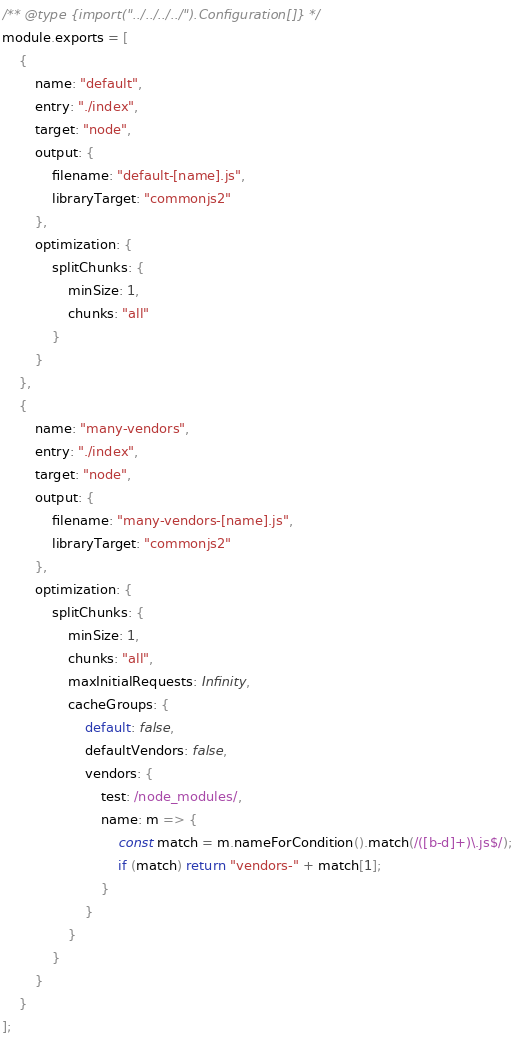<code> <loc_0><loc_0><loc_500><loc_500><_JavaScript_>/** @type {import("../../../../").Configuration[]} */
module.exports = [
	{
		name: "default",
		entry: "./index",
		target: "node",
		output: {
			filename: "default-[name].js",
			libraryTarget: "commonjs2"
		},
		optimization: {
			splitChunks: {
				minSize: 1,
				chunks: "all"
			}
		}
	},
	{
		name: "many-vendors",
		entry: "./index",
		target: "node",
		output: {
			filename: "many-vendors-[name].js",
			libraryTarget: "commonjs2"
		},
		optimization: {
			splitChunks: {
				minSize: 1,
				chunks: "all",
				maxInitialRequests: Infinity,
				cacheGroups: {
					default: false,
					defaultVendors: false,
					vendors: {
						test: /node_modules/,
						name: m => {
							const match = m.nameForCondition().match(/([b-d]+)\.js$/);
							if (match) return "vendors-" + match[1];
						}
					}
				}
			}
		}
	}
];
</code> 